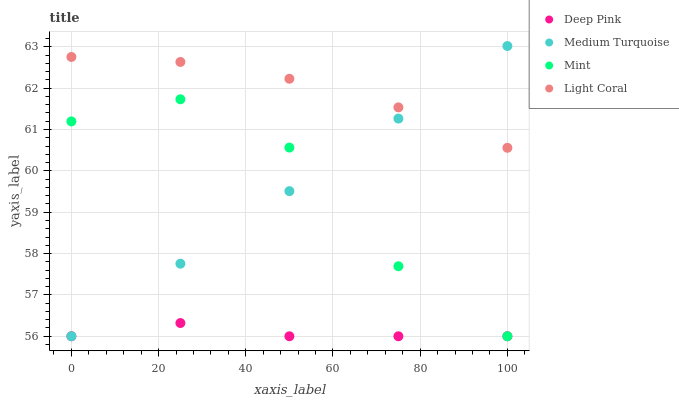Does Deep Pink have the minimum area under the curve?
Answer yes or no. Yes. Does Light Coral have the maximum area under the curve?
Answer yes or no. Yes. Does Mint have the minimum area under the curve?
Answer yes or no. No. Does Mint have the maximum area under the curve?
Answer yes or no. No. Is Medium Turquoise the smoothest?
Answer yes or no. Yes. Is Mint the roughest?
Answer yes or no. Yes. Is Deep Pink the smoothest?
Answer yes or no. No. Is Deep Pink the roughest?
Answer yes or no. No. Does Deep Pink have the lowest value?
Answer yes or no. Yes. Does Medium Turquoise have the highest value?
Answer yes or no. Yes. Does Mint have the highest value?
Answer yes or no. No. Is Deep Pink less than Light Coral?
Answer yes or no. Yes. Is Light Coral greater than Mint?
Answer yes or no. Yes. Does Light Coral intersect Medium Turquoise?
Answer yes or no. Yes. Is Light Coral less than Medium Turquoise?
Answer yes or no. No. Is Light Coral greater than Medium Turquoise?
Answer yes or no. No. Does Deep Pink intersect Light Coral?
Answer yes or no. No. 